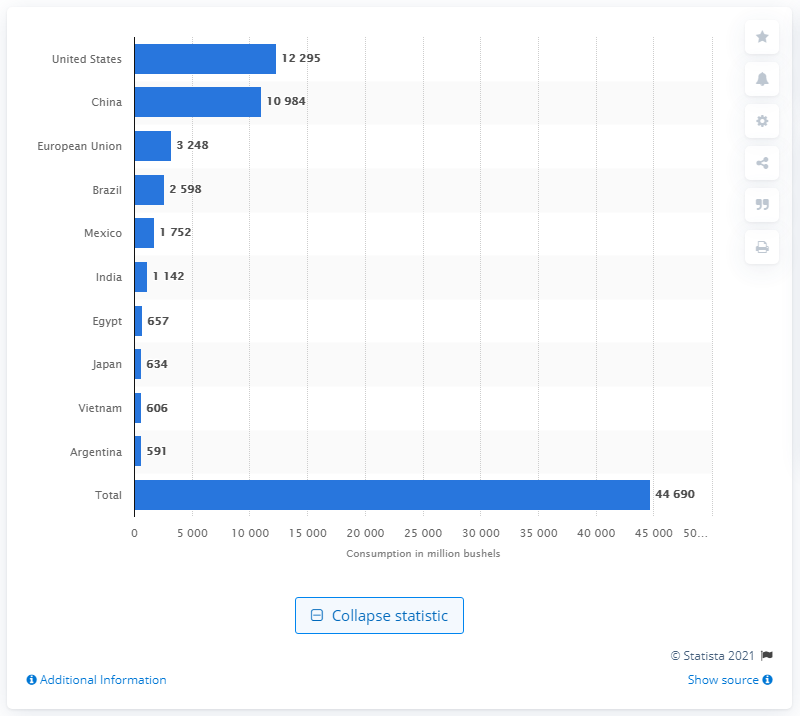Outline some significant characteristics in this image. In the 2019/2020 crop year, the United States consumed a total of 122,950 bushels of corn. In the 2019/2020 corn consumption cycle, China was the runner-up country. In the 2019/2020 crop year, China consumed a total of 109,840 metric tons of corn. 